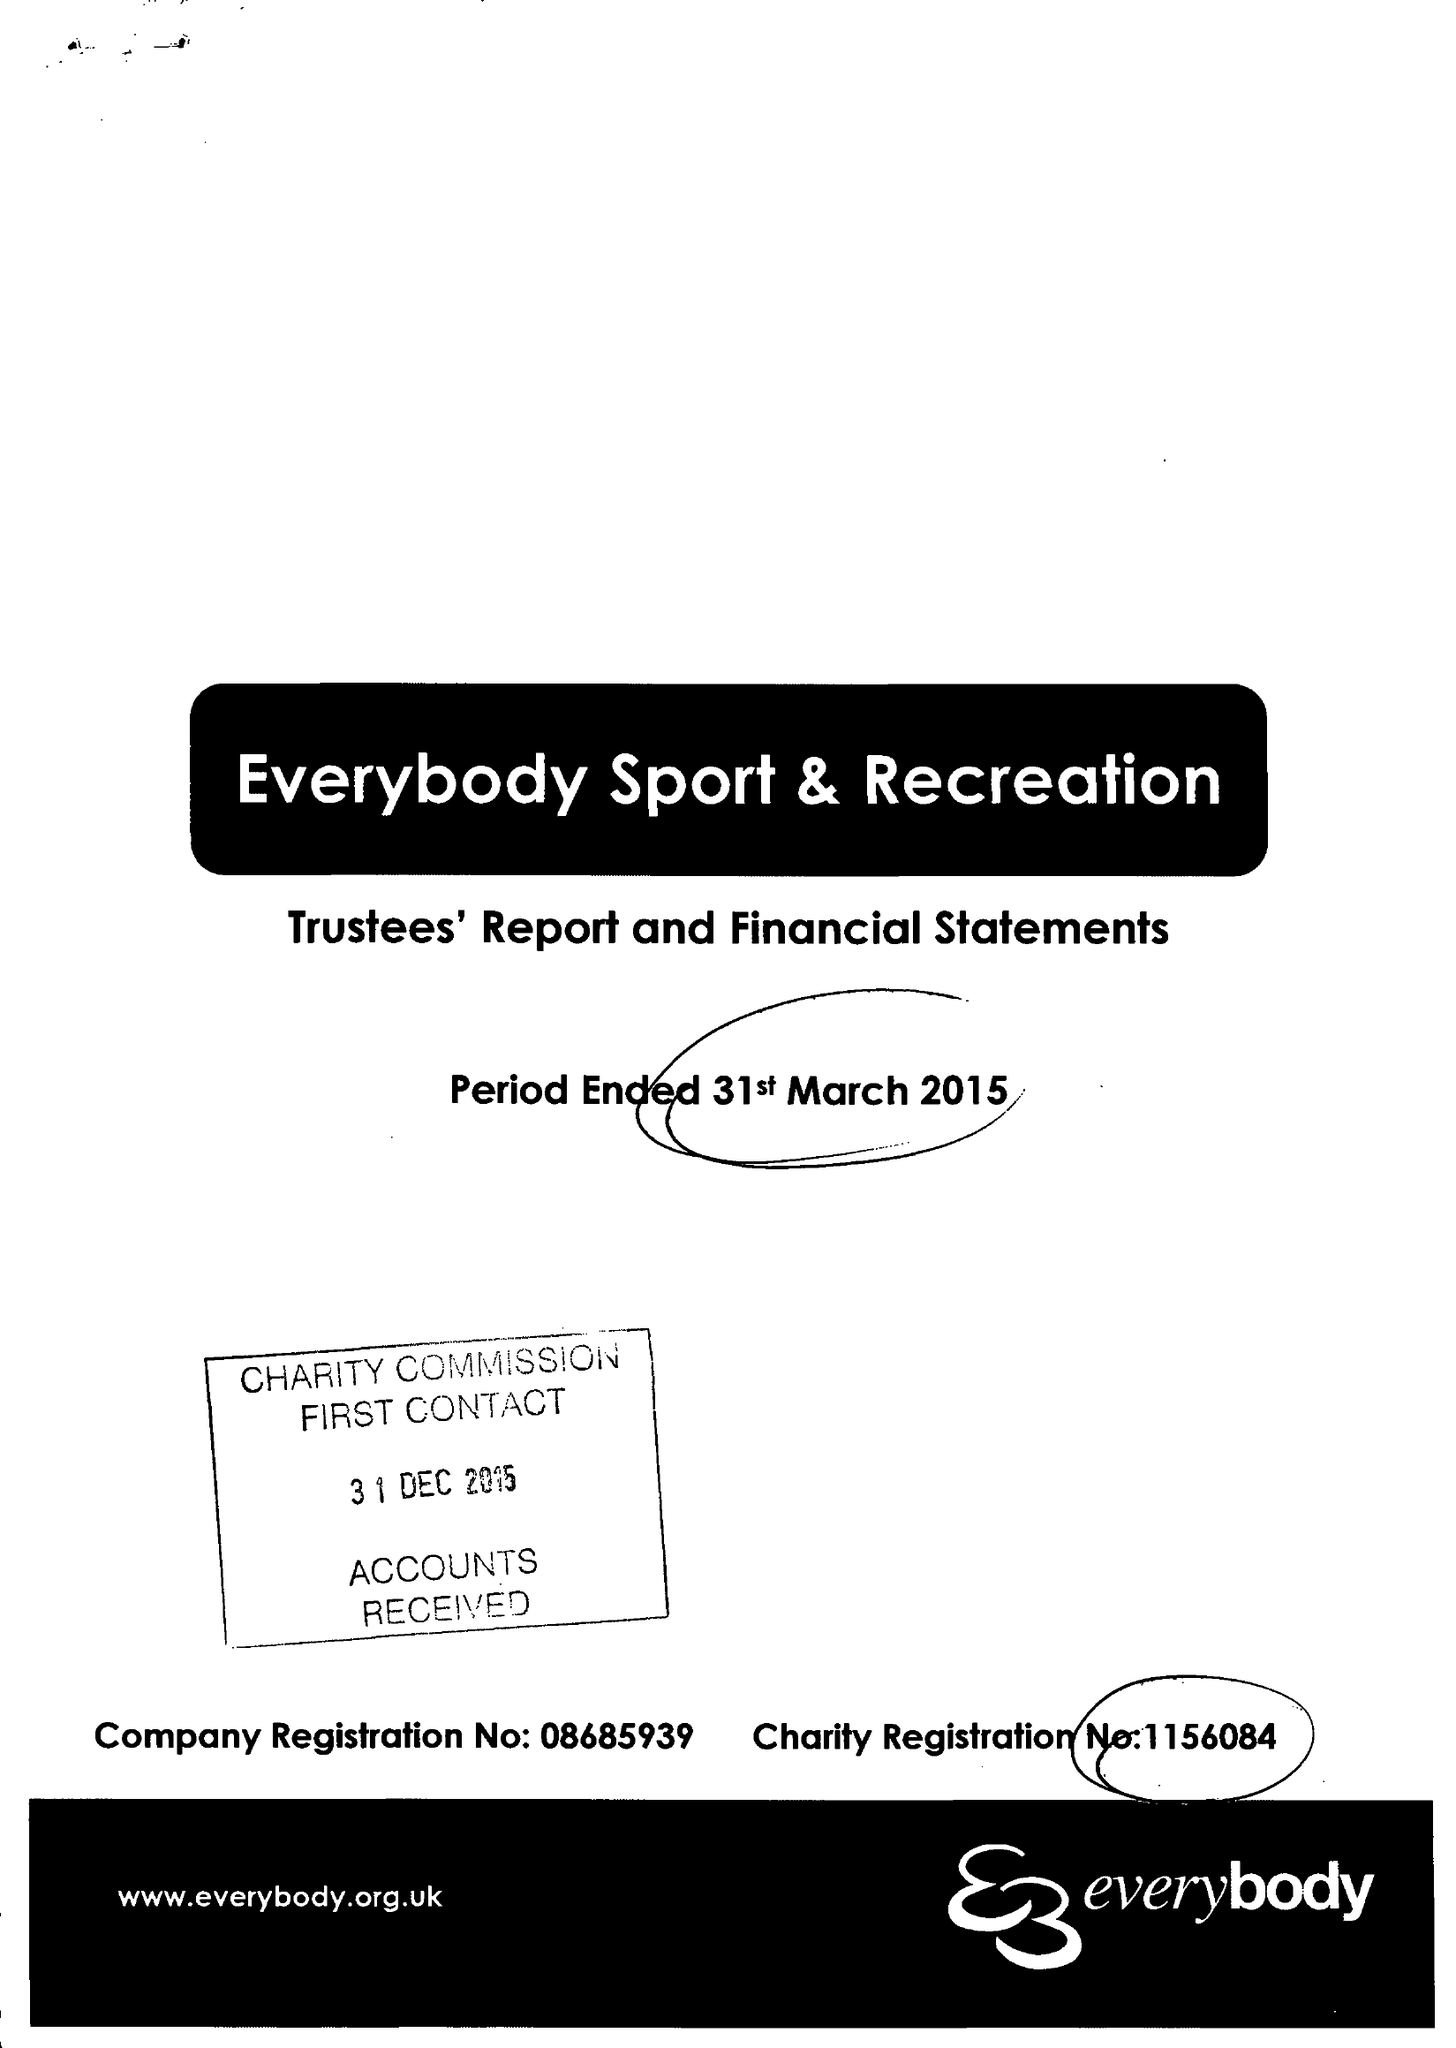What is the value for the charity_number?
Answer the question using a single word or phrase. 1156084 